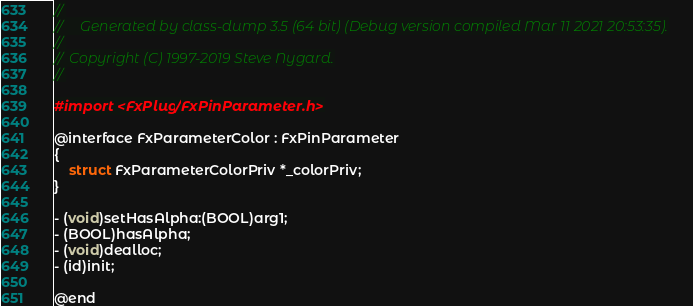<code> <loc_0><loc_0><loc_500><loc_500><_C_>//
//     Generated by class-dump 3.5 (64 bit) (Debug version compiled Mar 11 2021 20:53:35).
//
//  Copyright (C) 1997-2019 Steve Nygard.
//

#import <FxPlug/FxPinParameter.h>

@interface FxParameterColor : FxPinParameter
{
    struct FxParameterColorPriv *_colorPriv;
}

- (void)setHasAlpha:(BOOL)arg1;
- (BOOL)hasAlpha;
- (void)dealloc;
- (id)init;

@end

</code> 